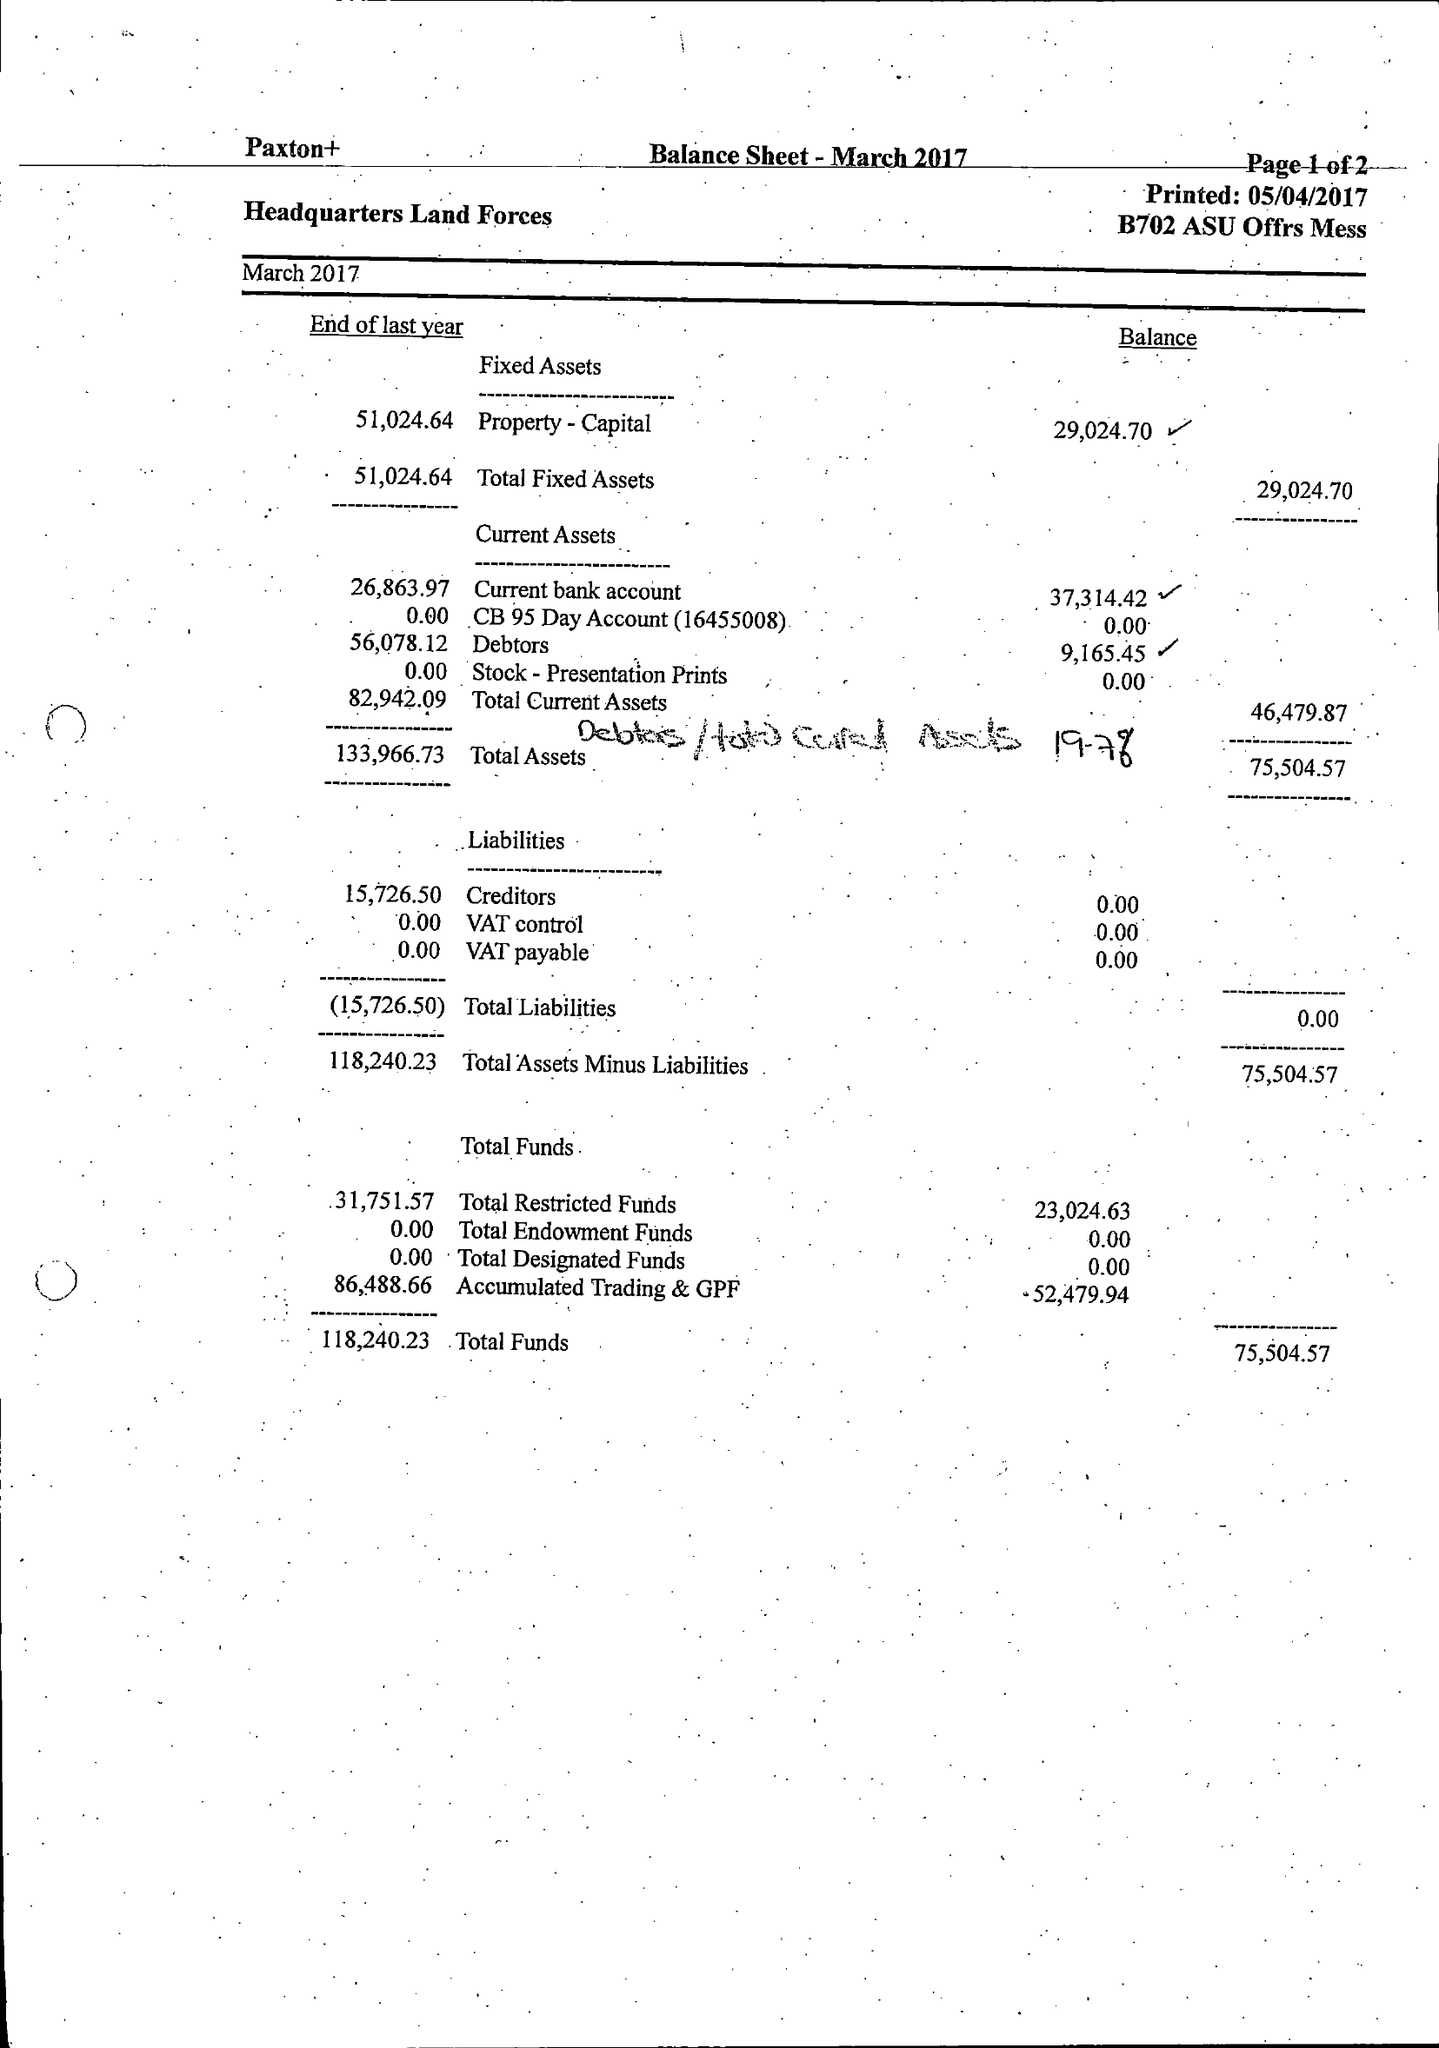What is the value for the spending_annually_in_british_pounds?
Answer the question using a single word or phrase. 140440.00 